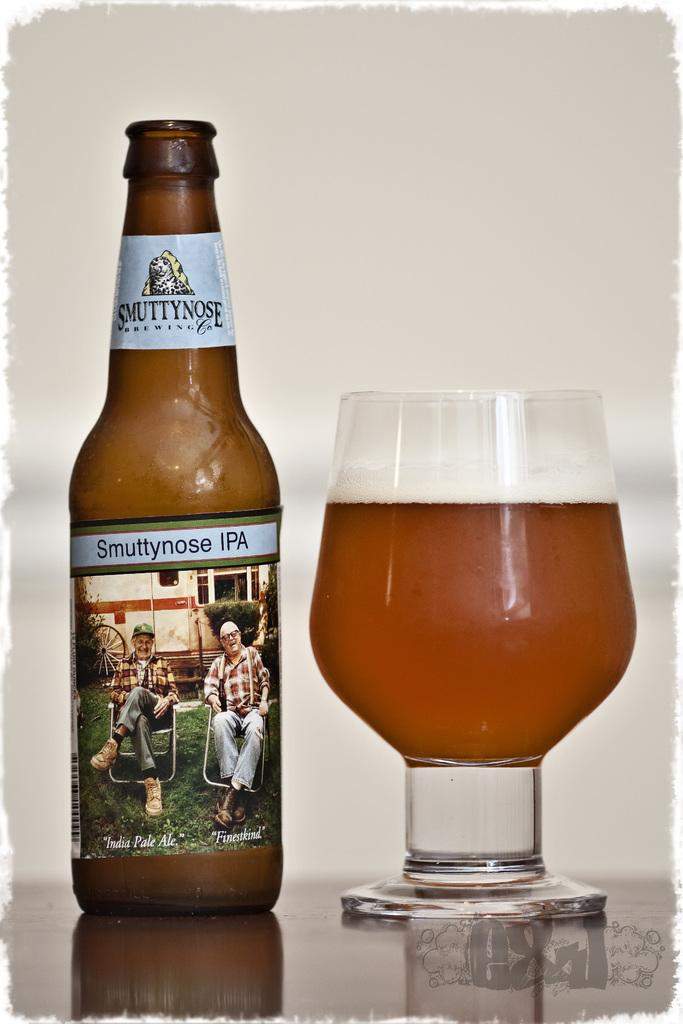<image>
Give a short and clear explanation of the subsequent image. Brown smuttynose IPA beer bottle showing two older men in lawn chairs. 